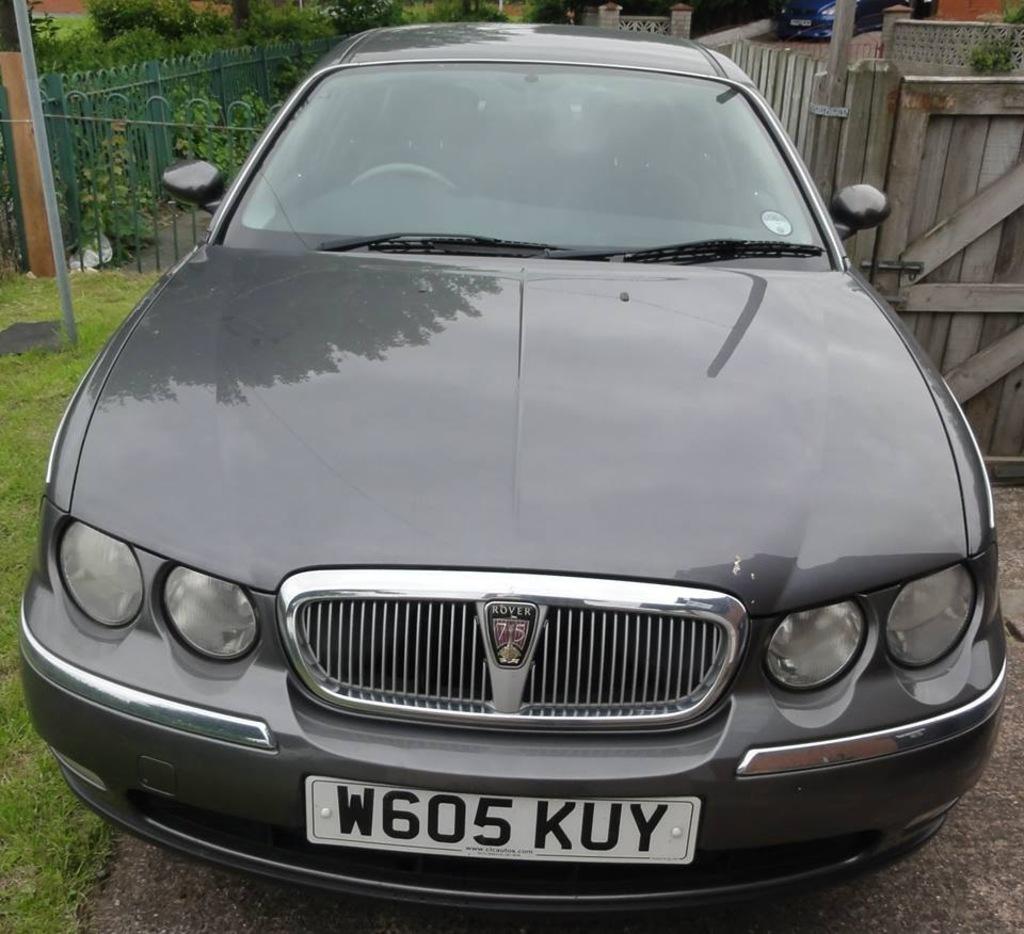What is the license plate number?
Offer a terse response. W605kuy. What is the licence plate number?
Give a very brief answer. W605kuy. 